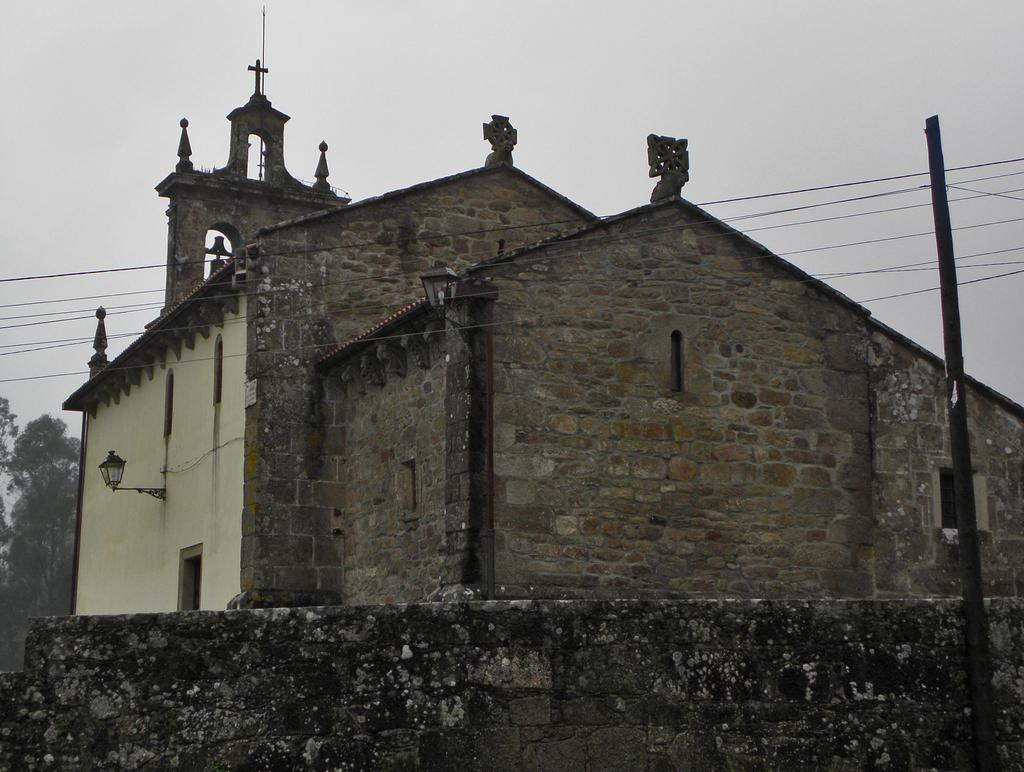What type of structure is present in the image? There is a building in the image. What is located in front of the building? There are cables and a pole in front of the building. What can be seen in the background of the image? There are trees visible in the background of the image. What advice does the grandmother give in the image? There is no grandmother present in the image, so it is not possible to answer that question. 